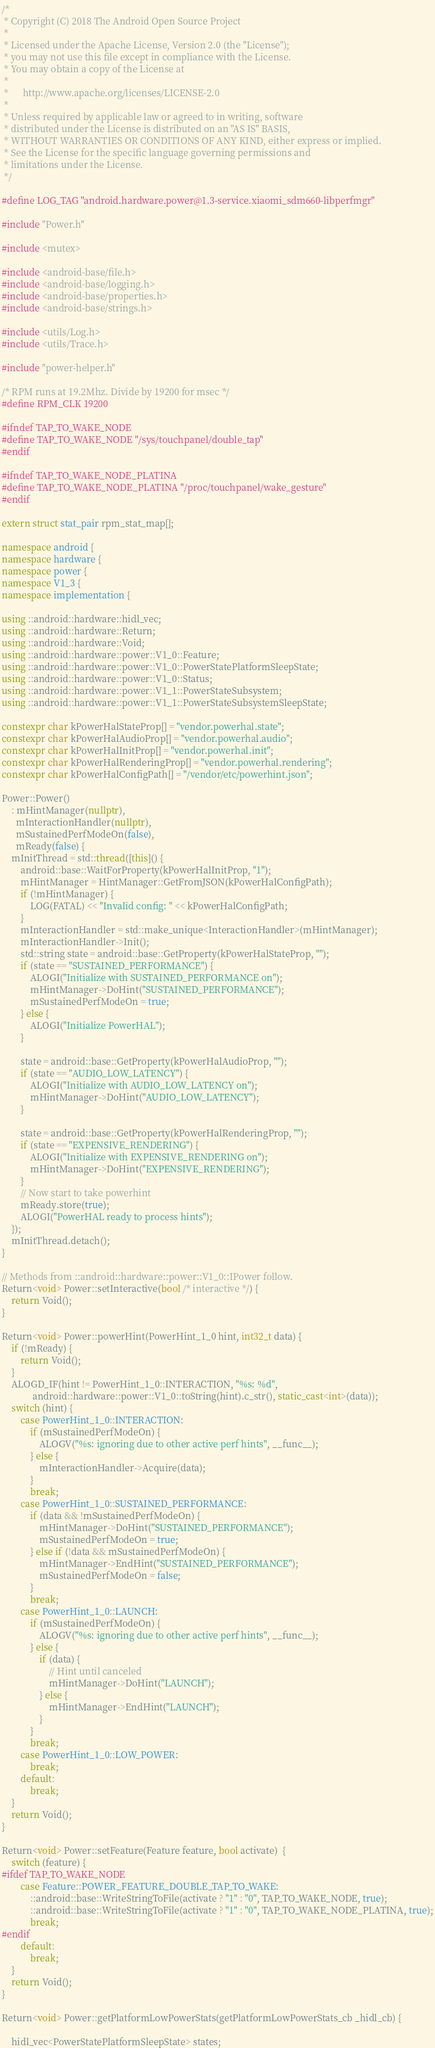<code> <loc_0><loc_0><loc_500><loc_500><_C++_>/*
 * Copyright (C) 2018 The Android Open Source Project
 *
 * Licensed under the Apache License, Version 2.0 (the "License");
 * you may not use this file except in compliance with the License.
 * You may obtain a copy of the License at
 *
 *      http://www.apache.org/licenses/LICENSE-2.0
 *
 * Unless required by applicable law or agreed to in writing, software
 * distributed under the License is distributed on an "AS IS" BASIS,
 * WITHOUT WARRANTIES OR CONDITIONS OF ANY KIND, either express or implied.
 * See the License for the specific language governing permissions and
 * limitations under the License.
 */

#define LOG_TAG "android.hardware.power@1.3-service.xiaomi_sdm660-libperfmgr"

#include "Power.h"

#include <mutex>

#include <android-base/file.h>
#include <android-base/logging.h>
#include <android-base/properties.h>
#include <android-base/strings.h>

#include <utils/Log.h>
#include <utils/Trace.h>

#include "power-helper.h"

/* RPM runs at 19.2Mhz. Divide by 19200 for msec */
#define RPM_CLK 19200

#ifndef TAP_TO_WAKE_NODE
#define TAP_TO_WAKE_NODE "/sys/touchpanel/double_tap"
#endif

#ifndef TAP_TO_WAKE_NODE_PLATINA
#define TAP_TO_WAKE_NODE_PLATINA "/proc/touchpanel/wake_gesture"
#endif

extern struct stat_pair rpm_stat_map[];

namespace android {
namespace hardware {
namespace power {
namespace V1_3 {
namespace implementation {

using ::android::hardware::hidl_vec;
using ::android::hardware::Return;
using ::android::hardware::Void;
using ::android::hardware::power::V1_0::Feature;
using ::android::hardware::power::V1_0::PowerStatePlatformSleepState;
using ::android::hardware::power::V1_0::Status;
using ::android::hardware::power::V1_1::PowerStateSubsystem;
using ::android::hardware::power::V1_1::PowerStateSubsystemSleepState;

constexpr char kPowerHalStateProp[] = "vendor.powerhal.state";
constexpr char kPowerHalAudioProp[] = "vendor.powerhal.audio";
constexpr char kPowerHalInitProp[] = "vendor.powerhal.init";
constexpr char kPowerHalRenderingProp[] = "vendor.powerhal.rendering";
constexpr char kPowerHalConfigPath[] = "/vendor/etc/powerhint.json";

Power::Power()
    : mHintManager(nullptr),
      mInteractionHandler(nullptr),
      mSustainedPerfModeOn(false),
      mReady(false) {
    mInitThread = std::thread([this]() {
        android::base::WaitForProperty(kPowerHalInitProp, "1");
        mHintManager = HintManager::GetFromJSON(kPowerHalConfigPath);
        if (!mHintManager) {
            LOG(FATAL) << "Invalid config: " << kPowerHalConfigPath;
        }
        mInteractionHandler = std::make_unique<InteractionHandler>(mHintManager);
        mInteractionHandler->Init();
        std::string state = android::base::GetProperty(kPowerHalStateProp, "");
        if (state == "SUSTAINED_PERFORMANCE") {
            ALOGI("Initialize with SUSTAINED_PERFORMANCE on");
            mHintManager->DoHint("SUSTAINED_PERFORMANCE");
            mSustainedPerfModeOn = true;
        } else {
            ALOGI("Initialize PowerHAL");
        }

        state = android::base::GetProperty(kPowerHalAudioProp, "");
        if (state == "AUDIO_LOW_LATENCY") {
            ALOGI("Initialize with AUDIO_LOW_LATENCY on");
            mHintManager->DoHint("AUDIO_LOW_LATENCY");
        }

        state = android::base::GetProperty(kPowerHalRenderingProp, "");
        if (state == "EXPENSIVE_RENDERING") {
            ALOGI("Initialize with EXPENSIVE_RENDERING on");
            mHintManager->DoHint("EXPENSIVE_RENDERING");
        }
        // Now start to take powerhint
        mReady.store(true);
        ALOGI("PowerHAL ready to process hints");
    });
    mInitThread.detach();
}

// Methods from ::android::hardware::power::V1_0::IPower follow.
Return<void> Power::setInteractive(bool /* interactive */) {
    return Void();
}

Return<void> Power::powerHint(PowerHint_1_0 hint, int32_t data) {
    if (!mReady) {
        return Void();
    }
    ALOGD_IF(hint != PowerHint_1_0::INTERACTION, "%s: %d",
             android::hardware::power::V1_0::toString(hint).c_str(), static_cast<int>(data));
    switch (hint) {
        case PowerHint_1_0::INTERACTION:
            if (mSustainedPerfModeOn) {
                ALOGV("%s: ignoring due to other active perf hints", __func__);
            } else {
                mInteractionHandler->Acquire(data);
            }
            break;
        case PowerHint_1_0::SUSTAINED_PERFORMANCE:
            if (data && !mSustainedPerfModeOn) {
                mHintManager->DoHint("SUSTAINED_PERFORMANCE");
                mSustainedPerfModeOn = true;
            } else if (!data && mSustainedPerfModeOn) {
                mHintManager->EndHint("SUSTAINED_PERFORMANCE");
                mSustainedPerfModeOn = false;
            }
            break;
        case PowerHint_1_0::LAUNCH:
            if (mSustainedPerfModeOn) {
                ALOGV("%s: ignoring due to other active perf hints", __func__);
            } else {
                if (data) {
                    // Hint until canceled
                    mHintManager->DoHint("LAUNCH");
                } else {
                    mHintManager->EndHint("LAUNCH");
                }
            }
            break;
        case PowerHint_1_0::LOW_POWER:
            break;
        default:
            break;
    }
    return Void();
}

Return<void> Power::setFeature(Feature feature, bool activate)  {
    switch (feature) {
#ifdef TAP_TO_WAKE_NODE
        case Feature::POWER_FEATURE_DOUBLE_TAP_TO_WAKE:
            ::android::base::WriteStringToFile(activate ? "1" : "0", TAP_TO_WAKE_NODE, true);
			::android::base::WriteStringToFile(activate ? "1" : "0", TAP_TO_WAKE_NODE_PLATINA, true);
            break;
#endif
        default:
            break;
    }
    return Void();
}

Return<void> Power::getPlatformLowPowerStats(getPlatformLowPowerStats_cb _hidl_cb) {

    hidl_vec<PowerStatePlatformSleepState> states;</code> 